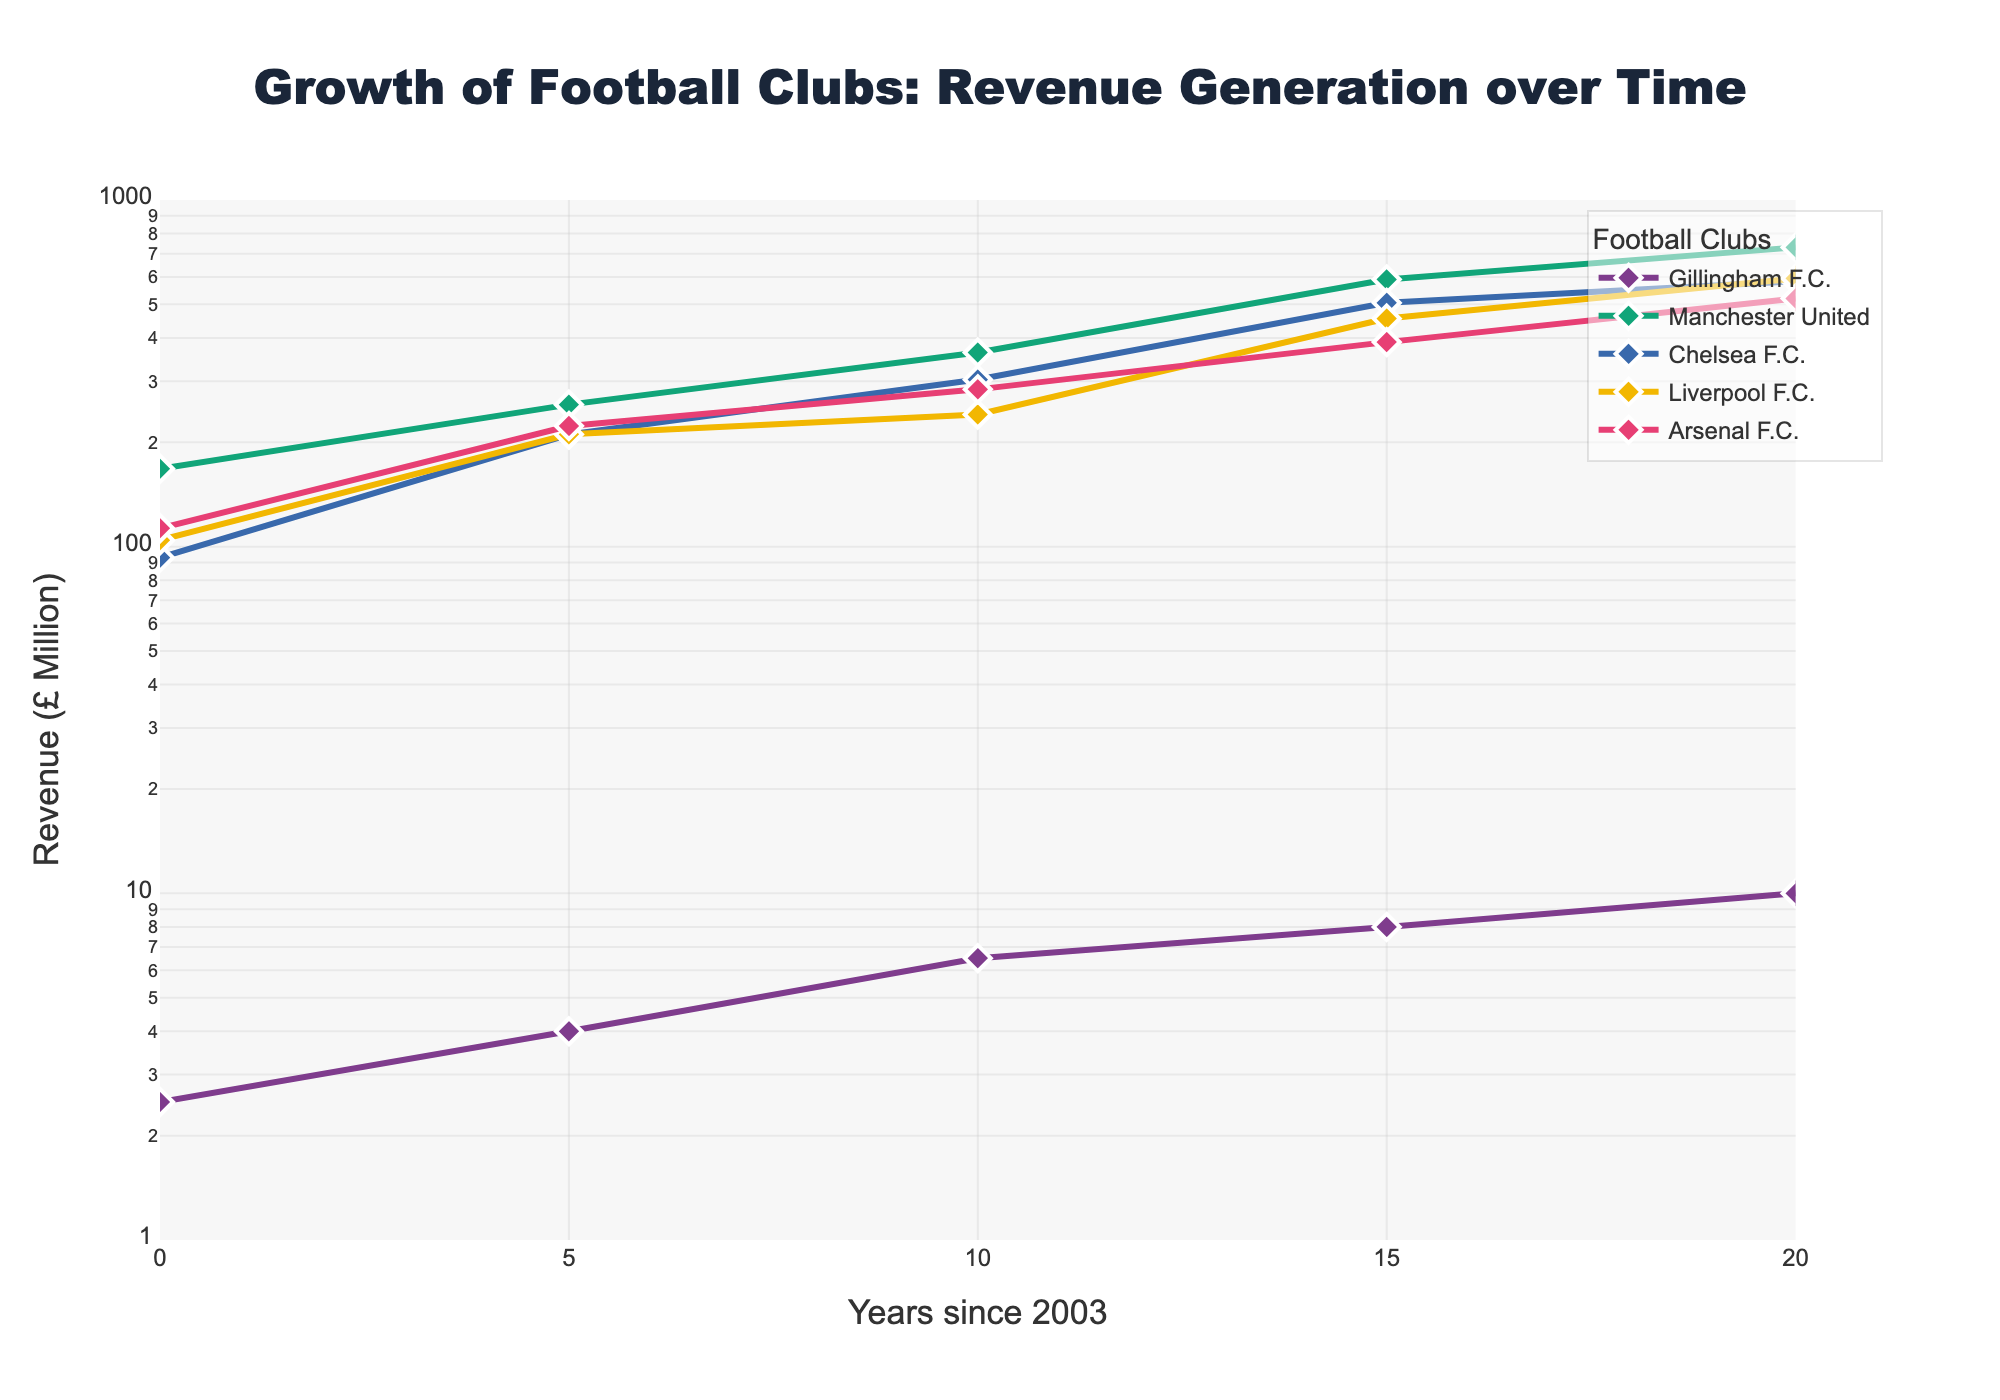How has Gillingham F.C.’s revenue grown from 2003 to 2023? To determine this, we look at Gillingham F.C.'s data points on the plot. In 2003, the revenue was £2.5 million, and in 2023, it has increased to £10.0 million. This shows a steady growth over 20 years.
Answer: Steady growth What is the title of the figure? The title is positioned at the top center of the figure. It typically provides a brief description of what the data represents.
Answer: Growth of Football Clubs: Revenue Generation over Time Which football club had the highest revenue in 2023? By observing the y-axis at the year 2023 and comparing the data points for each club, Manchester United has the highest revenue, indicated by the highest point on the log scale.
Answer: Manchester United How does the revenue growth of Manchester United compare to Chelsea F.C. from 2003 to 2023? To compare, look at the data points for both clubs over the years. In 2003, Manchester United's revenue was £167.7 million and Chelsea F.C.'s was £93.0 million. By 2023, Manchester United's revenue reached £730.0 million while Chelsea F.C.'s reached £583.0 million. Manchester United's revenue shows a larger absolute increase.
Answer: Manchester United's revenue grew more What is the revenue in 2013 for Liverpool F.C.? Find the data point on the plot at the intersection of 2013 (x-axis) and Liverpool F.C.’s line. The y-axis label corresponding to this data point reveals the revenue.
Answer: £240.6 million Which club showed the most exponential growth over the given years? By examining the slopes of each line on the log-scale plot, the line that rises the most sharply represents the most exponential growth. Manchester United's line appears to grow the steepest.
Answer: Manchester United How many data points are present for each club in the figure? Each club has data points for the years 2003, 2008, 2013, 2018, and 2023, totaling 5 data points per club as seen by the consistent markers along the x-axis.
Answer: 5 data points per club What is the y-axis range in the figure? The y-axis range can be determined by looking at the lowest and highest revenue values indicated on the axis. The plot spans from below £2.5 million (smallest value) up to £1000 million, although the highest actual value is £730.0 million for Manchester United in 2023.
Answer: £2.5 million to £1000 million (log scale) Which club had the smallest revenue in 2003? To find this, observe the y-values on the log-scale axis for the year 2003. The club with the lowest value in the figure is Gillingham F.C. with £2.5 million.
Answer: Gillingham F.C How frequently are the x-axis ticks spaced? The x-axis tick intervals can be observed under the data points which represent every 5 years starting from 0 (2003) up to 20 (2023).
Answer: Every 5 years 